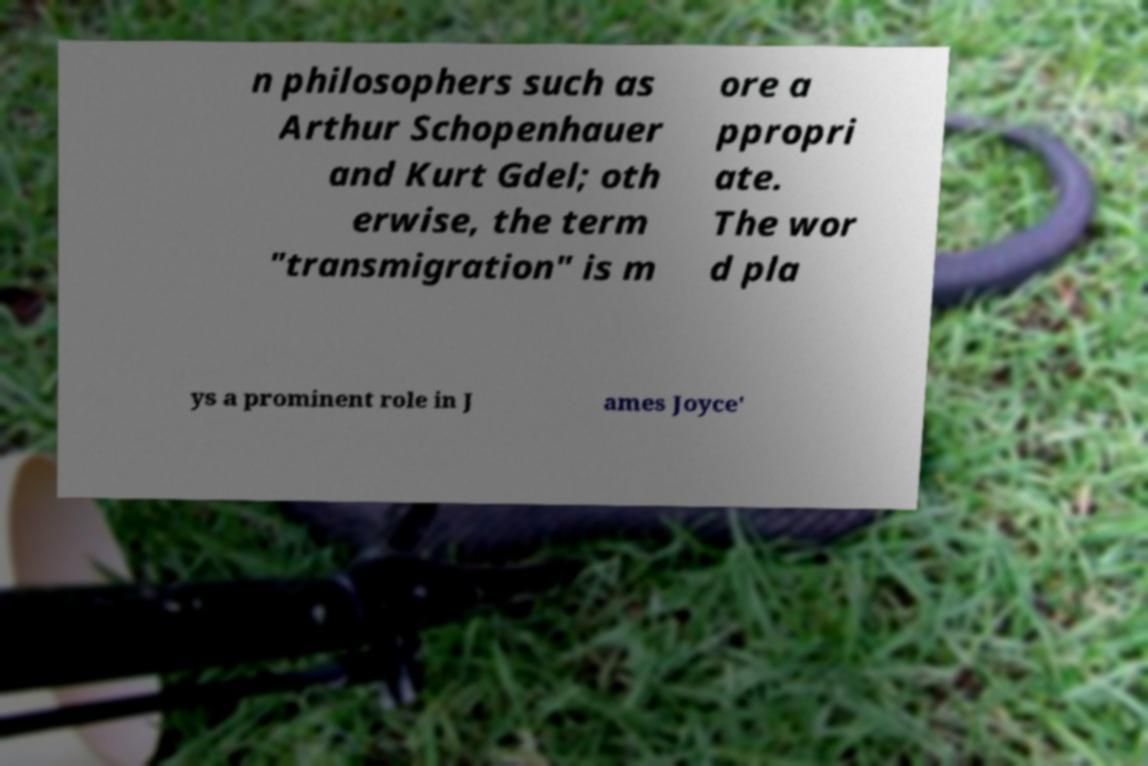Can you accurately transcribe the text from the provided image for me? n philosophers such as Arthur Schopenhauer and Kurt Gdel; oth erwise, the term "transmigration" is m ore a ppropri ate. The wor d pla ys a prominent role in J ames Joyce' 